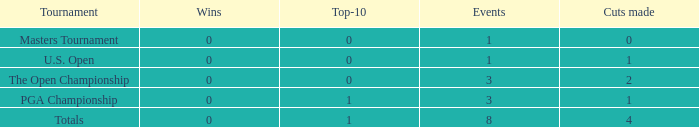For events with under 3 times played and fewer than 1 cut made, what is the total number of top-10 finishes? 1.0. 